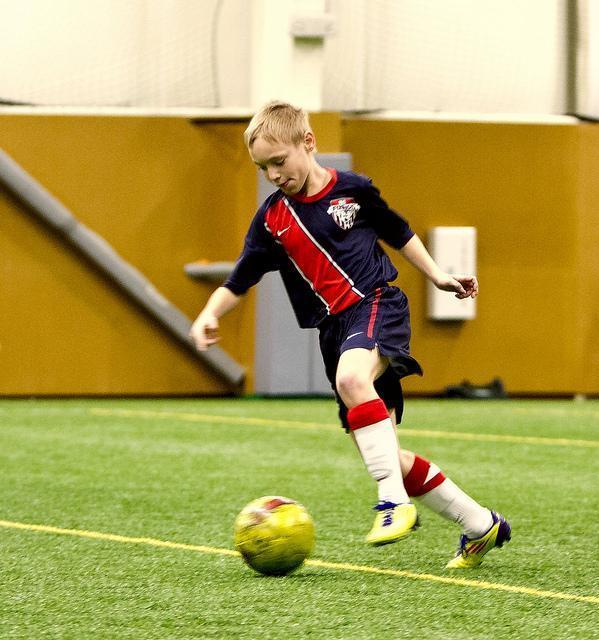How many people are wearing an orange shirt?
Give a very brief answer. 0. 